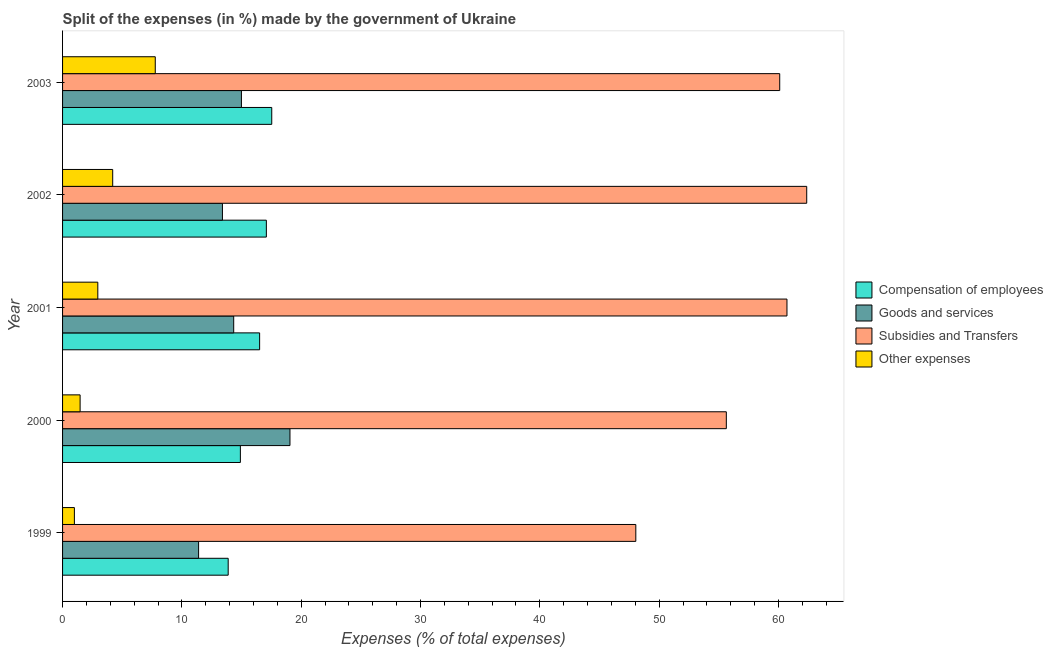How many different coloured bars are there?
Your answer should be very brief. 4. How many groups of bars are there?
Offer a very short reply. 5. Are the number of bars per tick equal to the number of legend labels?
Ensure brevity in your answer.  Yes. How many bars are there on the 5th tick from the top?
Keep it short and to the point. 4. In how many cases, is the number of bars for a given year not equal to the number of legend labels?
Provide a succinct answer. 0. What is the percentage of amount spent on goods and services in 2000?
Ensure brevity in your answer.  19.06. Across all years, what is the maximum percentage of amount spent on compensation of employees?
Give a very brief answer. 17.53. Across all years, what is the minimum percentage of amount spent on subsidies?
Your answer should be very brief. 48.04. In which year was the percentage of amount spent on compensation of employees maximum?
Keep it short and to the point. 2003. What is the total percentage of amount spent on goods and services in the graph?
Give a very brief answer. 73.19. What is the difference between the percentage of amount spent on subsidies in 2001 and that in 2003?
Ensure brevity in your answer.  0.61. What is the difference between the percentage of amount spent on subsidies in 2003 and the percentage of amount spent on goods and services in 2001?
Your answer should be compact. 45.76. What is the average percentage of amount spent on goods and services per year?
Offer a very short reply. 14.64. In the year 2002, what is the difference between the percentage of amount spent on goods and services and percentage of amount spent on compensation of employees?
Keep it short and to the point. -3.68. What is the ratio of the percentage of amount spent on subsidies in 2000 to that in 2003?
Give a very brief answer. 0.93. What is the difference between the highest and the second highest percentage of amount spent on goods and services?
Provide a short and direct response. 4.07. What is the difference between the highest and the lowest percentage of amount spent on compensation of employees?
Ensure brevity in your answer.  3.65. In how many years, is the percentage of amount spent on compensation of employees greater than the average percentage of amount spent on compensation of employees taken over all years?
Ensure brevity in your answer.  3. Is the sum of the percentage of amount spent on subsidies in 2002 and 2003 greater than the maximum percentage of amount spent on other expenses across all years?
Offer a very short reply. Yes. What does the 1st bar from the top in 2001 represents?
Offer a terse response. Other expenses. What does the 4th bar from the bottom in 2002 represents?
Offer a very short reply. Other expenses. Is it the case that in every year, the sum of the percentage of amount spent on compensation of employees and percentage of amount spent on goods and services is greater than the percentage of amount spent on subsidies?
Give a very brief answer. No. How many bars are there?
Provide a succinct answer. 20. Are all the bars in the graph horizontal?
Make the answer very short. Yes. How many years are there in the graph?
Your answer should be very brief. 5. What is the difference between two consecutive major ticks on the X-axis?
Give a very brief answer. 10. Are the values on the major ticks of X-axis written in scientific E-notation?
Give a very brief answer. No. Does the graph contain any zero values?
Make the answer very short. No. Where does the legend appear in the graph?
Keep it short and to the point. Center right. What is the title of the graph?
Give a very brief answer. Split of the expenses (in %) made by the government of Ukraine. Does "Secondary" appear as one of the legend labels in the graph?
Keep it short and to the point. No. What is the label or title of the X-axis?
Offer a terse response. Expenses (% of total expenses). What is the label or title of the Y-axis?
Your answer should be compact. Year. What is the Expenses (% of total expenses) of Compensation of employees in 1999?
Provide a short and direct response. 13.88. What is the Expenses (% of total expenses) in Goods and services in 1999?
Your response must be concise. 11.4. What is the Expenses (% of total expenses) of Subsidies and Transfers in 1999?
Make the answer very short. 48.04. What is the Expenses (% of total expenses) of Other expenses in 1999?
Offer a very short reply. 0.99. What is the Expenses (% of total expenses) of Compensation of employees in 2000?
Give a very brief answer. 14.9. What is the Expenses (% of total expenses) of Goods and services in 2000?
Offer a terse response. 19.06. What is the Expenses (% of total expenses) in Subsidies and Transfers in 2000?
Ensure brevity in your answer.  55.63. What is the Expenses (% of total expenses) of Other expenses in 2000?
Offer a very short reply. 1.47. What is the Expenses (% of total expenses) of Compensation of employees in 2001?
Make the answer very short. 16.51. What is the Expenses (% of total expenses) in Goods and services in 2001?
Offer a terse response. 14.34. What is the Expenses (% of total expenses) of Subsidies and Transfers in 2001?
Your answer should be compact. 60.71. What is the Expenses (% of total expenses) of Other expenses in 2001?
Provide a succinct answer. 2.95. What is the Expenses (% of total expenses) in Compensation of employees in 2002?
Keep it short and to the point. 17.08. What is the Expenses (% of total expenses) of Goods and services in 2002?
Offer a terse response. 13.4. What is the Expenses (% of total expenses) in Subsidies and Transfers in 2002?
Your answer should be compact. 62.37. What is the Expenses (% of total expenses) of Other expenses in 2002?
Provide a succinct answer. 4.2. What is the Expenses (% of total expenses) in Compensation of employees in 2003?
Offer a terse response. 17.53. What is the Expenses (% of total expenses) of Goods and services in 2003?
Your answer should be very brief. 14.99. What is the Expenses (% of total expenses) of Subsidies and Transfers in 2003?
Provide a short and direct response. 60.1. What is the Expenses (% of total expenses) in Other expenses in 2003?
Your response must be concise. 7.77. Across all years, what is the maximum Expenses (% of total expenses) of Compensation of employees?
Keep it short and to the point. 17.53. Across all years, what is the maximum Expenses (% of total expenses) of Goods and services?
Give a very brief answer. 19.06. Across all years, what is the maximum Expenses (% of total expenses) in Subsidies and Transfers?
Provide a short and direct response. 62.37. Across all years, what is the maximum Expenses (% of total expenses) in Other expenses?
Give a very brief answer. 7.77. Across all years, what is the minimum Expenses (% of total expenses) in Compensation of employees?
Your response must be concise. 13.88. Across all years, what is the minimum Expenses (% of total expenses) of Goods and services?
Give a very brief answer. 11.4. Across all years, what is the minimum Expenses (% of total expenses) in Subsidies and Transfers?
Offer a very short reply. 48.04. Across all years, what is the minimum Expenses (% of total expenses) in Other expenses?
Your answer should be very brief. 0.99. What is the total Expenses (% of total expenses) in Compensation of employees in the graph?
Make the answer very short. 79.91. What is the total Expenses (% of total expenses) of Goods and services in the graph?
Provide a succinct answer. 73.19. What is the total Expenses (% of total expenses) in Subsidies and Transfers in the graph?
Give a very brief answer. 286.85. What is the total Expenses (% of total expenses) in Other expenses in the graph?
Your answer should be very brief. 17.39. What is the difference between the Expenses (% of total expenses) in Compensation of employees in 1999 and that in 2000?
Offer a very short reply. -1.02. What is the difference between the Expenses (% of total expenses) in Goods and services in 1999 and that in 2000?
Provide a succinct answer. -7.66. What is the difference between the Expenses (% of total expenses) in Subsidies and Transfers in 1999 and that in 2000?
Offer a very short reply. -7.59. What is the difference between the Expenses (% of total expenses) in Other expenses in 1999 and that in 2000?
Ensure brevity in your answer.  -0.48. What is the difference between the Expenses (% of total expenses) of Compensation of employees in 1999 and that in 2001?
Provide a succinct answer. -2.63. What is the difference between the Expenses (% of total expenses) of Goods and services in 1999 and that in 2001?
Your answer should be compact. -2.94. What is the difference between the Expenses (% of total expenses) of Subsidies and Transfers in 1999 and that in 2001?
Your response must be concise. -12.67. What is the difference between the Expenses (% of total expenses) of Other expenses in 1999 and that in 2001?
Offer a very short reply. -1.96. What is the difference between the Expenses (% of total expenses) in Compensation of employees in 1999 and that in 2002?
Provide a succinct answer. -3.2. What is the difference between the Expenses (% of total expenses) of Goods and services in 1999 and that in 2002?
Make the answer very short. -2. What is the difference between the Expenses (% of total expenses) of Subsidies and Transfers in 1999 and that in 2002?
Keep it short and to the point. -14.32. What is the difference between the Expenses (% of total expenses) in Other expenses in 1999 and that in 2002?
Offer a very short reply. -3.21. What is the difference between the Expenses (% of total expenses) of Compensation of employees in 1999 and that in 2003?
Your answer should be very brief. -3.65. What is the difference between the Expenses (% of total expenses) of Goods and services in 1999 and that in 2003?
Keep it short and to the point. -3.59. What is the difference between the Expenses (% of total expenses) of Subsidies and Transfers in 1999 and that in 2003?
Your answer should be compact. -12.06. What is the difference between the Expenses (% of total expenses) in Other expenses in 1999 and that in 2003?
Offer a terse response. -6.78. What is the difference between the Expenses (% of total expenses) in Compensation of employees in 2000 and that in 2001?
Offer a terse response. -1.61. What is the difference between the Expenses (% of total expenses) of Goods and services in 2000 and that in 2001?
Give a very brief answer. 4.72. What is the difference between the Expenses (% of total expenses) in Subsidies and Transfers in 2000 and that in 2001?
Provide a succinct answer. -5.08. What is the difference between the Expenses (% of total expenses) in Other expenses in 2000 and that in 2001?
Your answer should be very brief. -1.48. What is the difference between the Expenses (% of total expenses) in Compensation of employees in 2000 and that in 2002?
Offer a very short reply. -2.18. What is the difference between the Expenses (% of total expenses) of Goods and services in 2000 and that in 2002?
Offer a terse response. 5.66. What is the difference between the Expenses (% of total expenses) of Subsidies and Transfers in 2000 and that in 2002?
Keep it short and to the point. -6.74. What is the difference between the Expenses (% of total expenses) in Other expenses in 2000 and that in 2002?
Make the answer very short. -2.73. What is the difference between the Expenses (% of total expenses) in Compensation of employees in 2000 and that in 2003?
Offer a terse response. -2.63. What is the difference between the Expenses (% of total expenses) of Goods and services in 2000 and that in 2003?
Give a very brief answer. 4.07. What is the difference between the Expenses (% of total expenses) in Subsidies and Transfers in 2000 and that in 2003?
Offer a terse response. -4.47. What is the difference between the Expenses (% of total expenses) of Other expenses in 2000 and that in 2003?
Provide a short and direct response. -6.3. What is the difference between the Expenses (% of total expenses) in Compensation of employees in 2001 and that in 2002?
Your answer should be compact. -0.57. What is the difference between the Expenses (% of total expenses) in Goods and services in 2001 and that in 2002?
Offer a terse response. 0.94. What is the difference between the Expenses (% of total expenses) of Subsidies and Transfers in 2001 and that in 2002?
Your answer should be very brief. -1.66. What is the difference between the Expenses (% of total expenses) of Other expenses in 2001 and that in 2002?
Give a very brief answer. -1.25. What is the difference between the Expenses (% of total expenses) in Compensation of employees in 2001 and that in 2003?
Ensure brevity in your answer.  -1.02. What is the difference between the Expenses (% of total expenses) in Goods and services in 2001 and that in 2003?
Your response must be concise. -0.65. What is the difference between the Expenses (% of total expenses) of Subsidies and Transfers in 2001 and that in 2003?
Offer a very short reply. 0.61. What is the difference between the Expenses (% of total expenses) in Other expenses in 2001 and that in 2003?
Keep it short and to the point. -4.81. What is the difference between the Expenses (% of total expenses) in Compensation of employees in 2002 and that in 2003?
Offer a terse response. -0.45. What is the difference between the Expenses (% of total expenses) in Goods and services in 2002 and that in 2003?
Your answer should be very brief. -1.59. What is the difference between the Expenses (% of total expenses) of Subsidies and Transfers in 2002 and that in 2003?
Provide a short and direct response. 2.26. What is the difference between the Expenses (% of total expenses) in Other expenses in 2002 and that in 2003?
Your response must be concise. -3.57. What is the difference between the Expenses (% of total expenses) in Compensation of employees in 1999 and the Expenses (% of total expenses) in Goods and services in 2000?
Your answer should be compact. -5.18. What is the difference between the Expenses (% of total expenses) of Compensation of employees in 1999 and the Expenses (% of total expenses) of Subsidies and Transfers in 2000?
Keep it short and to the point. -41.75. What is the difference between the Expenses (% of total expenses) in Compensation of employees in 1999 and the Expenses (% of total expenses) in Other expenses in 2000?
Make the answer very short. 12.41. What is the difference between the Expenses (% of total expenses) of Goods and services in 1999 and the Expenses (% of total expenses) of Subsidies and Transfers in 2000?
Offer a terse response. -44.23. What is the difference between the Expenses (% of total expenses) of Goods and services in 1999 and the Expenses (% of total expenses) of Other expenses in 2000?
Your response must be concise. 9.93. What is the difference between the Expenses (% of total expenses) in Subsidies and Transfers in 1999 and the Expenses (% of total expenses) in Other expenses in 2000?
Offer a terse response. 46.57. What is the difference between the Expenses (% of total expenses) of Compensation of employees in 1999 and the Expenses (% of total expenses) of Goods and services in 2001?
Offer a very short reply. -0.46. What is the difference between the Expenses (% of total expenses) of Compensation of employees in 1999 and the Expenses (% of total expenses) of Subsidies and Transfers in 2001?
Give a very brief answer. -46.83. What is the difference between the Expenses (% of total expenses) in Compensation of employees in 1999 and the Expenses (% of total expenses) in Other expenses in 2001?
Your response must be concise. 10.93. What is the difference between the Expenses (% of total expenses) in Goods and services in 1999 and the Expenses (% of total expenses) in Subsidies and Transfers in 2001?
Offer a very short reply. -49.31. What is the difference between the Expenses (% of total expenses) in Goods and services in 1999 and the Expenses (% of total expenses) in Other expenses in 2001?
Provide a succinct answer. 8.45. What is the difference between the Expenses (% of total expenses) of Subsidies and Transfers in 1999 and the Expenses (% of total expenses) of Other expenses in 2001?
Offer a terse response. 45.09. What is the difference between the Expenses (% of total expenses) of Compensation of employees in 1999 and the Expenses (% of total expenses) of Goods and services in 2002?
Your answer should be very brief. 0.48. What is the difference between the Expenses (% of total expenses) in Compensation of employees in 1999 and the Expenses (% of total expenses) in Subsidies and Transfers in 2002?
Offer a very short reply. -48.49. What is the difference between the Expenses (% of total expenses) of Compensation of employees in 1999 and the Expenses (% of total expenses) of Other expenses in 2002?
Your answer should be compact. 9.68. What is the difference between the Expenses (% of total expenses) of Goods and services in 1999 and the Expenses (% of total expenses) of Subsidies and Transfers in 2002?
Your answer should be very brief. -50.97. What is the difference between the Expenses (% of total expenses) in Goods and services in 1999 and the Expenses (% of total expenses) in Other expenses in 2002?
Keep it short and to the point. 7.2. What is the difference between the Expenses (% of total expenses) of Subsidies and Transfers in 1999 and the Expenses (% of total expenses) of Other expenses in 2002?
Make the answer very short. 43.84. What is the difference between the Expenses (% of total expenses) of Compensation of employees in 1999 and the Expenses (% of total expenses) of Goods and services in 2003?
Make the answer very short. -1.11. What is the difference between the Expenses (% of total expenses) in Compensation of employees in 1999 and the Expenses (% of total expenses) in Subsidies and Transfers in 2003?
Make the answer very short. -46.22. What is the difference between the Expenses (% of total expenses) of Compensation of employees in 1999 and the Expenses (% of total expenses) of Other expenses in 2003?
Give a very brief answer. 6.11. What is the difference between the Expenses (% of total expenses) in Goods and services in 1999 and the Expenses (% of total expenses) in Subsidies and Transfers in 2003?
Give a very brief answer. -48.7. What is the difference between the Expenses (% of total expenses) of Goods and services in 1999 and the Expenses (% of total expenses) of Other expenses in 2003?
Provide a succinct answer. 3.63. What is the difference between the Expenses (% of total expenses) in Subsidies and Transfers in 1999 and the Expenses (% of total expenses) in Other expenses in 2003?
Your response must be concise. 40.27. What is the difference between the Expenses (% of total expenses) of Compensation of employees in 2000 and the Expenses (% of total expenses) of Goods and services in 2001?
Ensure brevity in your answer.  0.56. What is the difference between the Expenses (% of total expenses) in Compensation of employees in 2000 and the Expenses (% of total expenses) in Subsidies and Transfers in 2001?
Provide a succinct answer. -45.81. What is the difference between the Expenses (% of total expenses) of Compensation of employees in 2000 and the Expenses (% of total expenses) of Other expenses in 2001?
Your answer should be very brief. 11.95. What is the difference between the Expenses (% of total expenses) of Goods and services in 2000 and the Expenses (% of total expenses) of Subsidies and Transfers in 2001?
Keep it short and to the point. -41.65. What is the difference between the Expenses (% of total expenses) in Goods and services in 2000 and the Expenses (% of total expenses) in Other expenses in 2001?
Your answer should be very brief. 16.1. What is the difference between the Expenses (% of total expenses) of Subsidies and Transfers in 2000 and the Expenses (% of total expenses) of Other expenses in 2001?
Your answer should be compact. 52.68. What is the difference between the Expenses (% of total expenses) of Compensation of employees in 2000 and the Expenses (% of total expenses) of Goods and services in 2002?
Your response must be concise. 1.5. What is the difference between the Expenses (% of total expenses) of Compensation of employees in 2000 and the Expenses (% of total expenses) of Subsidies and Transfers in 2002?
Offer a terse response. -47.46. What is the difference between the Expenses (% of total expenses) in Compensation of employees in 2000 and the Expenses (% of total expenses) in Other expenses in 2002?
Make the answer very short. 10.7. What is the difference between the Expenses (% of total expenses) in Goods and services in 2000 and the Expenses (% of total expenses) in Subsidies and Transfers in 2002?
Make the answer very short. -43.31. What is the difference between the Expenses (% of total expenses) of Goods and services in 2000 and the Expenses (% of total expenses) of Other expenses in 2002?
Provide a succinct answer. 14.86. What is the difference between the Expenses (% of total expenses) in Subsidies and Transfers in 2000 and the Expenses (% of total expenses) in Other expenses in 2002?
Give a very brief answer. 51.43. What is the difference between the Expenses (% of total expenses) of Compensation of employees in 2000 and the Expenses (% of total expenses) of Goods and services in 2003?
Offer a terse response. -0.09. What is the difference between the Expenses (% of total expenses) of Compensation of employees in 2000 and the Expenses (% of total expenses) of Subsidies and Transfers in 2003?
Your answer should be compact. -45.2. What is the difference between the Expenses (% of total expenses) of Compensation of employees in 2000 and the Expenses (% of total expenses) of Other expenses in 2003?
Give a very brief answer. 7.13. What is the difference between the Expenses (% of total expenses) in Goods and services in 2000 and the Expenses (% of total expenses) in Subsidies and Transfers in 2003?
Offer a terse response. -41.04. What is the difference between the Expenses (% of total expenses) in Goods and services in 2000 and the Expenses (% of total expenses) in Other expenses in 2003?
Ensure brevity in your answer.  11.29. What is the difference between the Expenses (% of total expenses) of Subsidies and Transfers in 2000 and the Expenses (% of total expenses) of Other expenses in 2003?
Provide a short and direct response. 47.86. What is the difference between the Expenses (% of total expenses) in Compensation of employees in 2001 and the Expenses (% of total expenses) in Goods and services in 2002?
Make the answer very short. 3.12. What is the difference between the Expenses (% of total expenses) in Compensation of employees in 2001 and the Expenses (% of total expenses) in Subsidies and Transfers in 2002?
Your response must be concise. -45.85. What is the difference between the Expenses (% of total expenses) of Compensation of employees in 2001 and the Expenses (% of total expenses) of Other expenses in 2002?
Your answer should be compact. 12.31. What is the difference between the Expenses (% of total expenses) in Goods and services in 2001 and the Expenses (% of total expenses) in Subsidies and Transfers in 2002?
Your answer should be compact. -48.02. What is the difference between the Expenses (% of total expenses) of Goods and services in 2001 and the Expenses (% of total expenses) of Other expenses in 2002?
Your answer should be very brief. 10.14. What is the difference between the Expenses (% of total expenses) in Subsidies and Transfers in 2001 and the Expenses (% of total expenses) in Other expenses in 2002?
Ensure brevity in your answer.  56.51. What is the difference between the Expenses (% of total expenses) in Compensation of employees in 2001 and the Expenses (% of total expenses) in Goods and services in 2003?
Your answer should be very brief. 1.52. What is the difference between the Expenses (% of total expenses) of Compensation of employees in 2001 and the Expenses (% of total expenses) of Subsidies and Transfers in 2003?
Your response must be concise. -43.59. What is the difference between the Expenses (% of total expenses) in Compensation of employees in 2001 and the Expenses (% of total expenses) in Other expenses in 2003?
Provide a short and direct response. 8.75. What is the difference between the Expenses (% of total expenses) in Goods and services in 2001 and the Expenses (% of total expenses) in Subsidies and Transfers in 2003?
Ensure brevity in your answer.  -45.76. What is the difference between the Expenses (% of total expenses) of Goods and services in 2001 and the Expenses (% of total expenses) of Other expenses in 2003?
Keep it short and to the point. 6.57. What is the difference between the Expenses (% of total expenses) of Subsidies and Transfers in 2001 and the Expenses (% of total expenses) of Other expenses in 2003?
Make the answer very short. 52.94. What is the difference between the Expenses (% of total expenses) in Compensation of employees in 2002 and the Expenses (% of total expenses) in Goods and services in 2003?
Make the answer very short. 2.09. What is the difference between the Expenses (% of total expenses) of Compensation of employees in 2002 and the Expenses (% of total expenses) of Subsidies and Transfers in 2003?
Provide a succinct answer. -43.02. What is the difference between the Expenses (% of total expenses) in Compensation of employees in 2002 and the Expenses (% of total expenses) in Other expenses in 2003?
Provide a short and direct response. 9.31. What is the difference between the Expenses (% of total expenses) in Goods and services in 2002 and the Expenses (% of total expenses) in Subsidies and Transfers in 2003?
Keep it short and to the point. -46.7. What is the difference between the Expenses (% of total expenses) of Goods and services in 2002 and the Expenses (% of total expenses) of Other expenses in 2003?
Make the answer very short. 5.63. What is the difference between the Expenses (% of total expenses) of Subsidies and Transfers in 2002 and the Expenses (% of total expenses) of Other expenses in 2003?
Offer a very short reply. 54.6. What is the average Expenses (% of total expenses) of Compensation of employees per year?
Keep it short and to the point. 15.98. What is the average Expenses (% of total expenses) in Goods and services per year?
Your answer should be very brief. 14.64. What is the average Expenses (% of total expenses) in Subsidies and Transfers per year?
Ensure brevity in your answer.  57.37. What is the average Expenses (% of total expenses) of Other expenses per year?
Keep it short and to the point. 3.48. In the year 1999, what is the difference between the Expenses (% of total expenses) of Compensation of employees and Expenses (% of total expenses) of Goods and services?
Your answer should be very brief. 2.48. In the year 1999, what is the difference between the Expenses (% of total expenses) in Compensation of employees and Expenses (% of total expenses) in Subsidies and Transfers?
Provide a short and direct response. -34.16. In the year 1999, what is the difference between the Expenses (% of total expenses) of Compensation of employees and Expenses (% of total expenses) of Other expenses?
Your answer should be very brief. 12.89. In the year 1999, what is the difference between the Expenses (% of total expenses) in Goods and services and Expenses (% of total expenses) in Subsidies and Transfers?
Provide a short and direct response. -36.64. In the year 1999, what is the difference between the Expenses (% of total expenses) of Goods and services and Expenses (% of total expenses) of Other expenses?
Your answer should be very brief. 10.41. In the year 1999, what is the difference between the Expenses (% of total expenses) in Subsidies and Transfers and Expenses (% of total expenses) in Other expenses?
Keep it short and to the point. 47.05. In the year 2000, what is the difference between the Expenses (% of total expenses) of Compensation of employees and Expenses (% of total expenses) of Goods and services?
Your response must be concise. -4.16. In the year 2000, what is the difference between the Expenses (% of total expenses) in Compensation of employees and Expenses (% of total expenses) in Subsidies and Transfers?
Your answer should be very brief. -40.73. In the year 2000, what is the difference between the Expenses (% of total expenses) of Compensation of employees and Expenses (% of total expenses) of Other expenses?
Provide a succinct answer. 13.43. In the year 2000, what is the difference between the Expenses (% of total expenses) of Goods and services and Expenses (% of total expenses) of Subsidies and Transfers?
Your answer should be very brief. -36.57. In the year 2000, what is the difference between the Expenses (% of total expenses) of Goods and services and Expenses (% of total expenses) of Other expenses?
Offer a terse response. 17.59. In the year 2000, what is the difference between the Expenses (% of total expenses) in Subsidies and Transfers and Expenses (% of total expenses) in Other expenses?
Offer a very short reply. 54.16. In the year 2001, what is the difference between the Expenses (% of total expenses) of Compensation of employees and Expenses (% of total expenses) of Goods and services?
Offer a terse response. 2.17. In the year 2001, what is the difference between the Expenses (% of total expenses) of Compensation of employees and Expenses (% of total expenses) of Subsidies and Transfers?
Provide a succinct answer. -44.2. In the year 2001, what is the difference between the Expenses (% of total expenses) of Compensation of employees and Expenses (% of total expenses) of Other expenses?
Ensure brevity in your answer.  13.56. In the year 2001, what is the difference between the Expenses (% of total expenses) of Goods and services and Expenses (% of total expenses) of Subsidies and Transfers?
Your answer should be compact. -46.37. In the year 2001, what is the difference between the Expenses (% of total expenses) of Goods and services and Expenses (% of total expenses) of Other expenses?
Give a very brief answer. 11.39. In the year 2001, what is the difference between the Expenses (% of total expenses) in Subsidies and Transfers and Expenses (% of total expenses) in Other expenses?
Give a very brief answer. 57.76. In the year 2002, what is the difference between the Expenses (% of total expenses) of Compensation of employees and Expenses (% of total expenses) of Goods and services?
Your answer should be very brief. 3.68. In the year 2002, what is the difference between the Expenses (% of total expenses) in Compensation of employees and Expenses (% of total expenses) in Subsidies and Transfers?
Give a very brief answer. -45.29. In the year 2002, what is the difference between the Expenses (% of total expenses) of Compensation of employees and Expenses (% of total expenses) of Other expenses?
Provide a succinct answer. 12.88. In the year 2002, what is the difference between the Expenses (% of total expenses) of Goods and services and Expenses (% of total expenses) of Subsidies and Transfers?
Keep it short and to the point. -48.97. In the year 2002, what is the difference between the Expenses (% of total expenses) of Goods and services and Expenses (% of total expenses) of Other expenses?
Your response must be concise. 9.2. In the year 2002, what is the difference between the Expenses (% of total expenses) of Subsidies and Transfers and Expenses (% of total expenses) of Other expenses?
Ensure brevity in your answer.  58.16. In the year 2003, what is the difference between the Expenses (% of total expenses) of Compensation of employees and Expenses (% of total expenses) of Goods and services?
Keep it short and to the point. 2.54. In the year 2003, what is the difference between the Expenses (% of total expenses) of Compensation of employees and Expenses (% of total expenses) of Subsidies and Transfers?
Offer a terse response. -42.57. In the year 2003, what is the difference between the Expenses (% of total expenses) of Compensation of employees and Expenses (% of total expenses) of Other expenses?
Keep it short and to the point. 9.76. In the year 2003, what is the difference between the Expenses (% of total expenses) in Goods and services and Expenses (% of total expenses) in Subsidies and Transfers?
Ensure brevity in your answer.  -45.11. In the year 2003, what is the difference between the Expenses (% of total expenses) in Goods and services and Expenses (% of total expenses) in Other expenses?
Provide a short and direct response. 7.22. In the year 2003, what is the difference between the Expenses (% of total expenses) in Subsidies and Transfers and Expenses (% of total expenses) in Other expenses?
Ensure brevity in your answer.  52.33. What is the ratio of the Expenses (% of total expenses) of Compensation of employees in 1999 to that in 2000?
Your response must be concise. 0.93. What is the ratio of the Expenses (% of total expenses) in Goods and services in 1999 to that in 2000?
Your response must be concise. 0.6. What is the ratio of the Expenses (% of total expenses) in Subsidies and Transfers in 1999 to that in 2000?
Give a very brief answer. 0.86. What is the ratio of the Expenses (% of total expenses) of Other expenses in 1999 to that in 2000?
Keep it short and to the point. 0.67. What is the ratio of the Expenses (% of total expenses) of Compensation of employees in 1999 to that in 2001?
Offer a very short reply. 0.84. What is the ratio of the Expenses (% of total expenses) of Goods and services in 1999 to that in 2001?
Your answer should be very brief. 0.79. What is the ratio of the Expenses (% of total expenses) of Subsidies and Transfers in 1999 to that in 2001?
Your response must be concise. 0.79. What is the ratio of the Expenses (% of total expenses) in Other expenses in 1999 to that in 2001?
Your response must be concise. 0.34. What is the ratio of the Expenses (% of total expenses) in Compensation of employees in 1999 to that in 2002?
Your answer should be very brief. 0.81. What is the ratio of the Expenses (% of total expenses) in Goods and services in 1999 to that in 2002?
Offer a terse response. 0.85. What is the ratio of the Expenses (% of total expenses) in Subsidies and Transfers in 1999 to that in 2002?
Offer a terse response. 0.77. What is the ratio of the Expenses (% of total expenses) in Other expenses in 1999 to that in 2002?
Your answer should be compact. 0.24. What is the ratio of the Expenses (% of total expenses) in Compensation of employees in 1999 to that in 2003?
Provide a short and direct response. 0.79. What is the ratio of the Expenses (% of total expenses) in Goods and services in 1999 to that in 2003?
Give a very brief answer. 0.76. What is the ratio of the Expenses (% of total expenses) in Subsidies and Transfers in 1999 to that in 2003?
Provide a succinct answer. 0.8. What is the ratio of the Expenses (% of total expenses) of Other expenses in 1999 to that in 2003?
Your answer should be compact. 0.13. What is the ratio of the Expenses (% of total expenses) in Compensation of employees in 2000 to that in 2001?
Offer a terse response. 0.9. What is the ratio of the Expenses (% of total expenses) of Goods and services in 2000 to that in 2001?
Keep it short and to the point. 1.33. What is the ratio of the Expenses (% of total expenses) in Subsidies and Transfers in 2000 to that in 2001?
Your response must be concise. 0.92. What is the ratio of the Expenses (% of total expenses) in Other expenses in 2000 to that in 2001?
Your answer should be compact. 0.5. What is the ratio of the Expenses (% of total expenses) in Compensation of employees in 2000 to that in 2002?
Ensure brevity in your answer.  0.87. What is the ratio of the Expenses (% of total expenses) in Goods and services in 2000 to that in 2002?
Make the answer very short. 1.42. What is the ratio of the Expenses (% of total expenses) of Subsidies and Transfers in 2000 to that in 2002?
Ensure brevity in your answer.  0.89. What is the ratio of the Expenses (% of total expenses) of Compensation of employees in 2000 to that in 2003?
Offer a terse response. 0.85. What is the ratio of the Expenses (% of total expenses) in Goods and services in 2000 to that in 2003?
Keep it short and to the point. 1.27. What is the ratio of the Expenses (% of total expenses) of Subsidies and Transfers in 2000 to that in 2003?
Ensure brevity in your answer.  0.93. What is the ratio of the Expenses (% of total expenses) in Other expenses in 2000 to that in 2003?
Ensure brevity in your answer.  0.19. What is the ratio of the Expenses (% of total expenses) of Compensation of employees in 2001 to that in 2002?
Your answer should be compact. 0.97. What is the ratio of the Expenses (% of total expenses) in Goods and services in 2001 to that in 2002?
Provide a short and direct response. 1.07. What is the ratio of the Expenses (% of total expenses) of Subsidies and Transfers in 2001 to that in 2002?
Your response must be concise. 0.97. What is the ratio of the Expenses (% of total expenses) in Other expenses in 2001 to that in 2002?
Your answer should be very brief. 0.7. What is the ratio of the Expenses (% of total expenses) of Compensation of employees in 2001 to that in 2003?
Your response must be concise. 0.94. What is the ratio of the Expenses (% of total expenses) of Goods and services in 2001 to that in 2003?
Your response must be concise. 0.96. What is the ratio of the Expenses (% of total expenses) in Other expenses in 2001 to that in 2003?
Provide a succinct answer. 0.38. What is the ratio of the Expenses (% of total expenses) of Compensation of employees in 2002 to that in 2003?
Your response must be concise. 0.97. What is the ratio of the Expenses (% of total expenses) in Goods and services in 2002 to that in 2003?
Offer a very short reply. 0.89. What is the ratio of the Expenses (% of total expenses) of Subsidies and Transfers in 2002 to that in 2003?
Ensure brevity in your answer.  1.04. What is the ratio of the Expenses (% of total expenses) of Other expenses in 2002 to that in 2003?
Give a very brief answer. 0.54. What is the difference between the highest and the second highest Expenses (% of total expenses) in Compensation of employees?
Your answer should be very brief. 0.45. What is the difference between the highest and the second highest Expenses (% of total expenses) of Goods and services?
Your answer should be compact. 4.07. What is the difference between the highest and the second highest Expenses (% of total expenses) in Subsidies and Transfers?
Your answer should be compact. 1.66. What is the difference between the highest and the second highest Expenses (% of total expenses) in Other expenses?
Your response must be concise. 3.57. What is the difference between the highest and the lowest Expenses (% of total expenses) of Compensation of employees?
Offer a very short reply. 3.65. What is the difference between the highest and the lowest Expenses (% of total expenses) in Goods and services?
Your answer should be very brief. 7.66. What is the difference between the highest and the lowest Expenses (% of total expenses) in Subsidies and Transfers?
Offer a very short reply. 14.32. What is the difference between the highest and the lowest Expenses (% of total expenses) in Other expenses?
Your response must be concise. 6.78. 